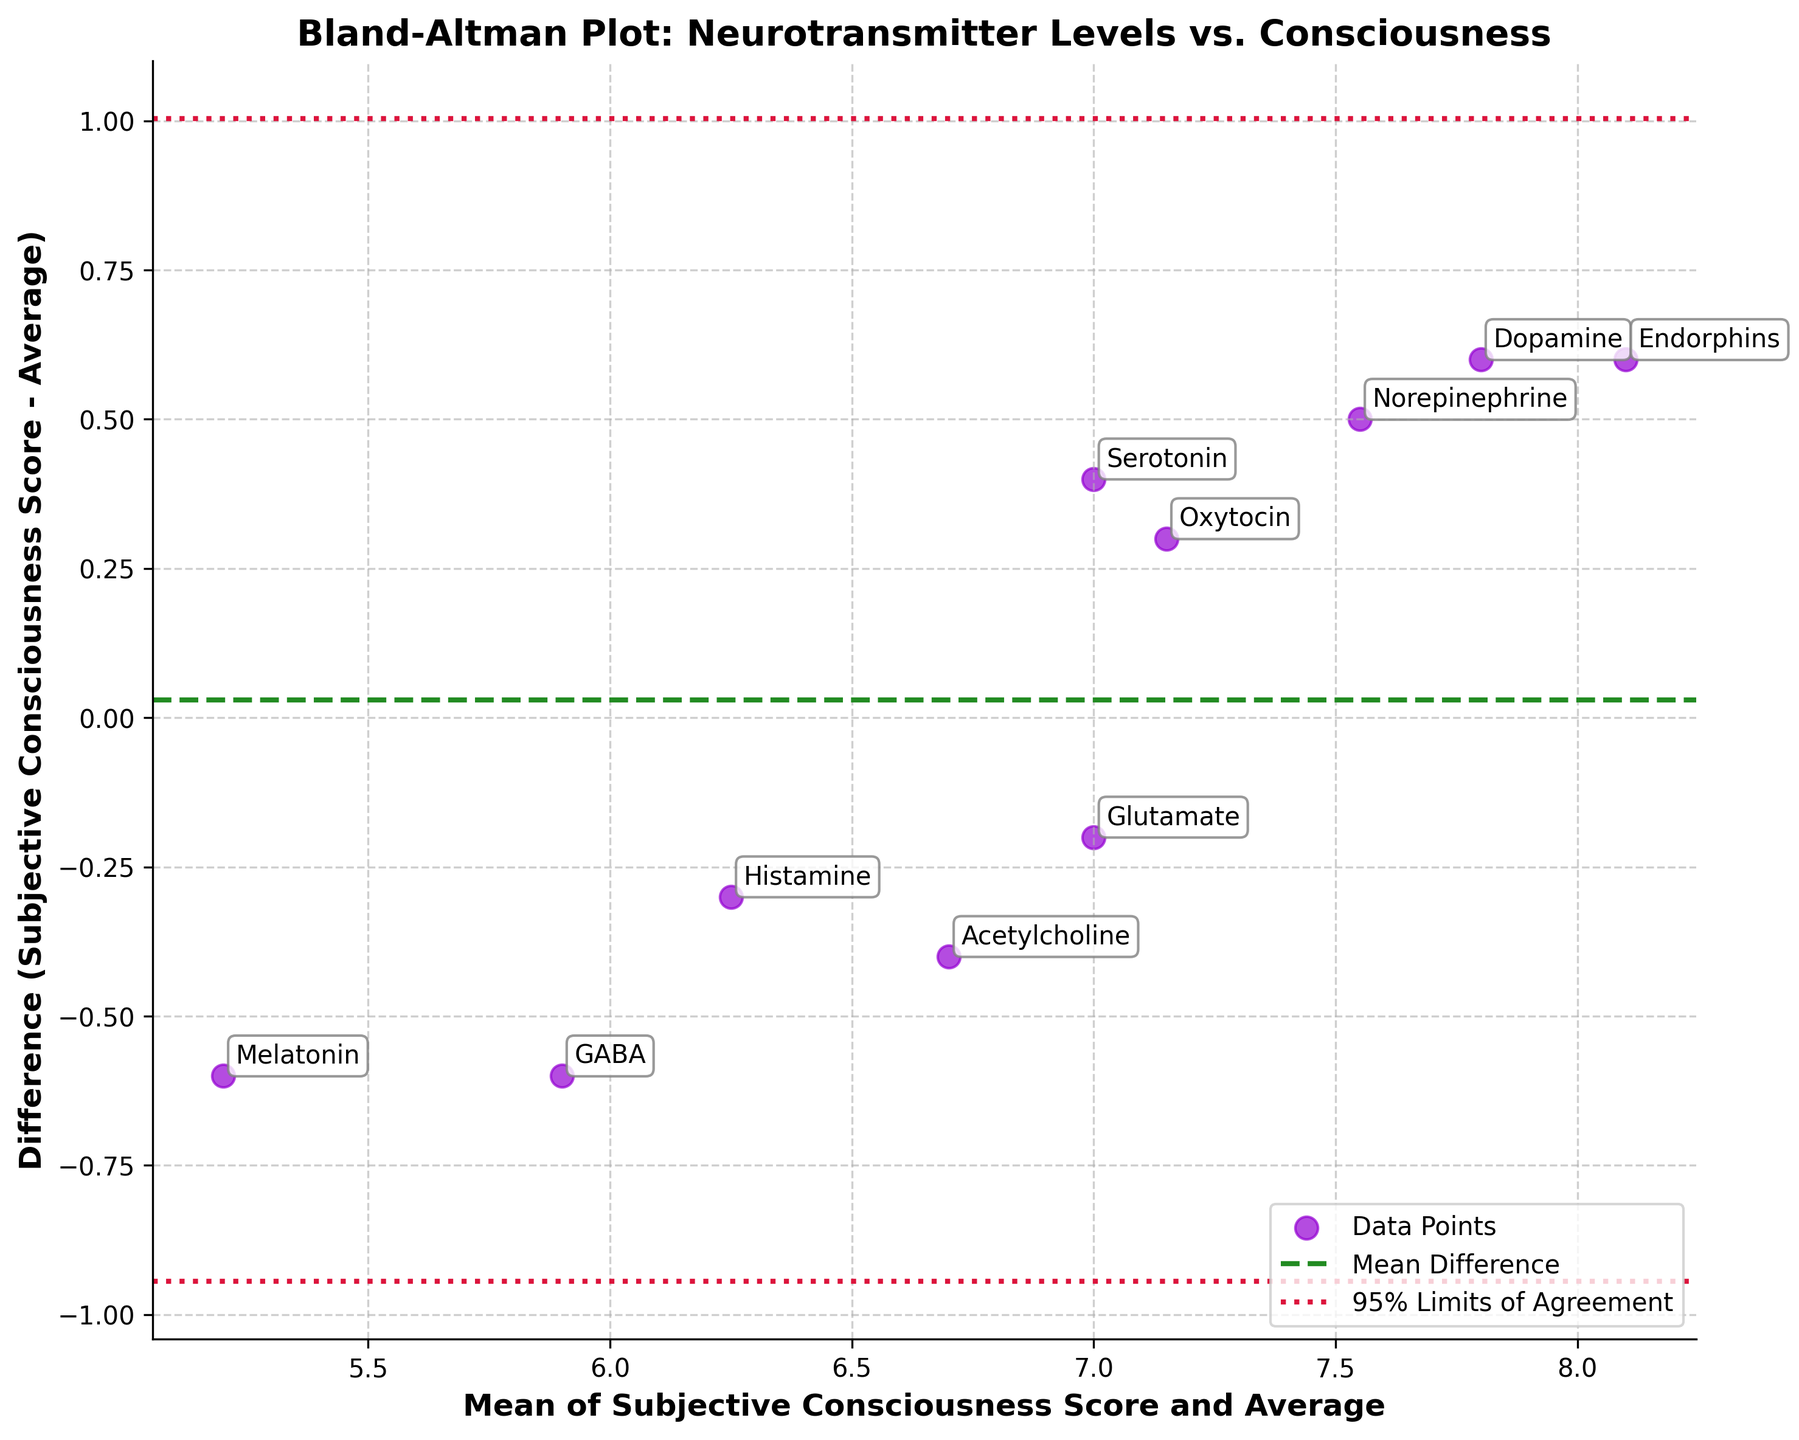What's the title of the plot? The title is displayed at the top center of the plot in bold text. It reads "Bland-Altman Plot: Neurotransmitter Levels vs. Consciousness".
Answer: Bland-Altman Plot: Neurotransmitter Levels vs. Consciousness How many data points are shown in the plot? Each data point corresponds to a neurotransmitter, and each one is labeled in the plot to show the respective value.
Answer: 10 What does the dotted green horizontal line represent? The dotted green horizontal line represents the mean difference between the Subjective Consciousness Score and the Average.
Answer: Mean difference What are the values of the upper and lower limits of agreement? The upper and lower limits of agreement are indicated by the dotted crimson lines. These values are computed as mean difference ± 1.96 times the standard deviation of the differences. Using the mean difference and standard deviation displayed on the plot, these values can be calculated.
Answer: Requires plot values What is the highest difference value, and for which neurotransmitter does it occur? The highest difference is indicated by the data point farthest above the mean difference line. Checking the plot, Oxytocin shows the highest difference.
Answer: Oxytocin Which neurotransmitter has the smallest difference, and what is its value? The smallest difference is the point closest to the x-axis (mean difference line). Observing the plot, Melatonin has the smallest difference.
Answer: Melatonin What do the x-axis and y-axis represent? The x-axis represents the mean of the Subjective Consciousness Score and Average, while the y-axis represents the difference between the Subjective Consciousness Score and the Average.
Answer: Mean of Subjective Consciousness Score and Average, Difference How many neurotransmitters have differences above the mean difference line? To count the neurotransmitters above the mean difference line, count the data points located above the green line on the y-axis.
Answer: 6 Compare the differences in scores between Serotonin and Dopamine. Which one is higher? Locate Serotonin and Dopamine on the plot to compare their y-values (differences). Dopamine has a higher score difference than Serotonin.
Answer: Dopamine Is there any neurotransmitter whose difference falls exactly on the mean difference line? Look for a data point that coincides directly on the mean difference line (green). According to the plot, no data point falls precisely on this line.
Answer: No 